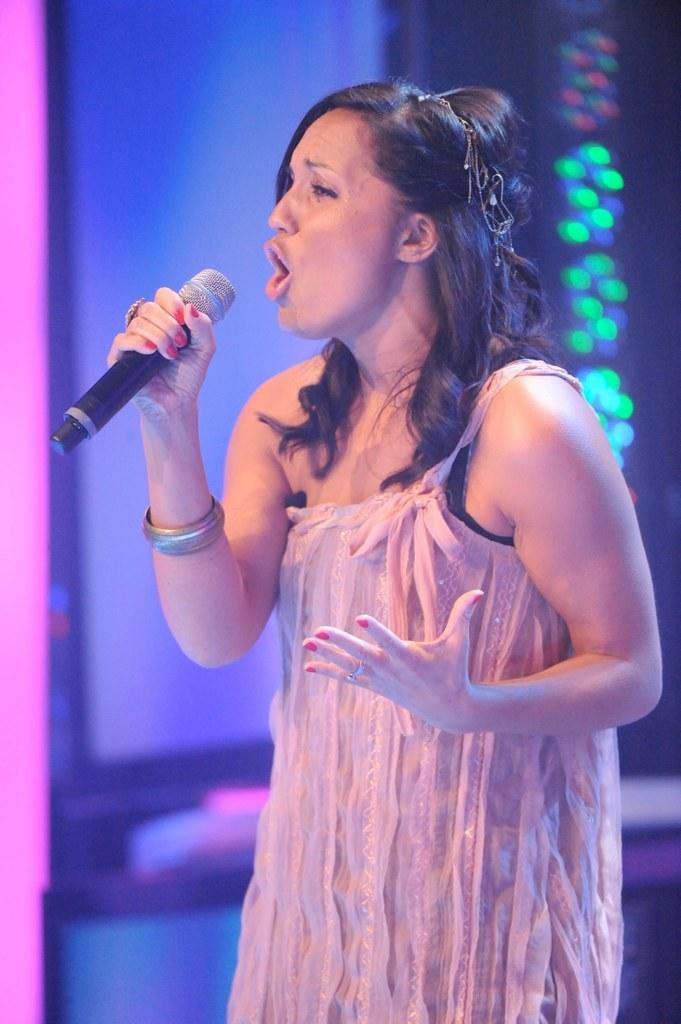What is the lady in the image doing? The lady is singing in the image. How can we tell that the lady is singing? The lady's mouth is open, and she is holding a microphone. What is the lady wearing? The lady is wearing a pink dress. What can be seen in the background of the image? There is light in the background of the image. What type of cheese is being served in the lunchroom in the image? There is no lunchroom or cheese present in the image; it features a lady singing while holding a microphone. 